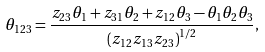<formula> <loc_0><loc_0><loc_500><loc_500>\theta _ { 1 2 3 } = \frac { z _ { 2 3 } \theta _ { 1 } + z _ { 3 1 } \theta _ { 2 } + z _ { 1 2 } \theta _ { 3 } - \theta _ { 1 } \theta _ { 2 } \theta _ { 3 } } { \left ( z _ { 1 2 } z _ { 1 3 } z _ { 2 3 } \right ) ^ { 1 / 2 } } ,</formula> 